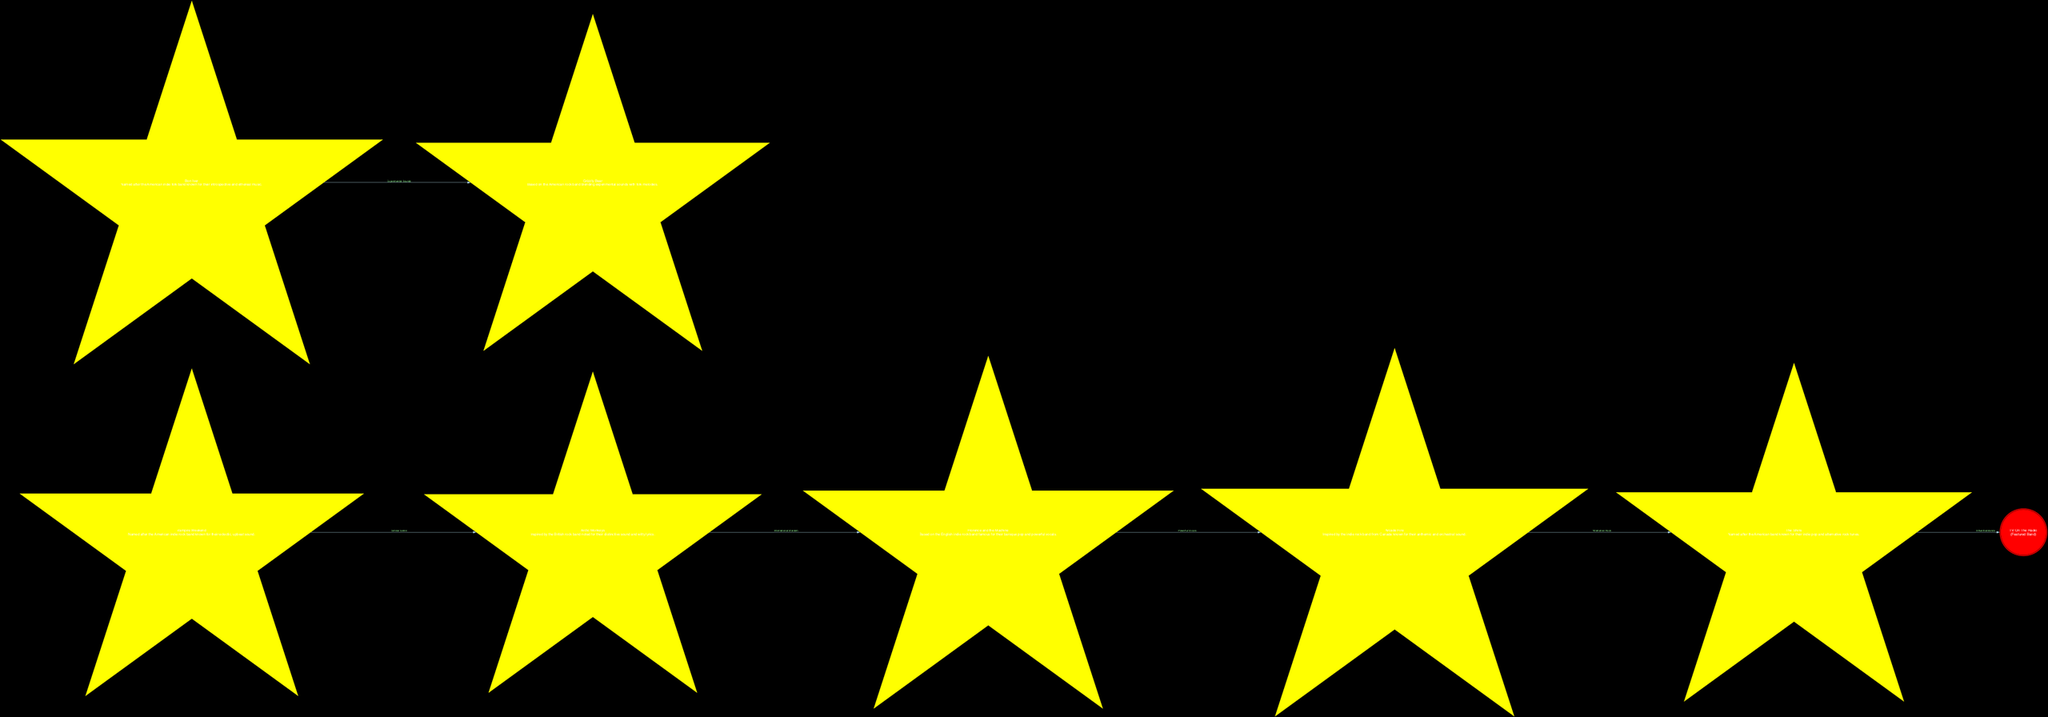What is the name of the constellation featuring the band known for blending genres like punk, soul, and electronic music? The constellation that features the band known for blending genres like punk, soul, and electronic music is "TV On The Radio". This is confirmed by identifying the specific constellation in the diagram.
Answer: TV On The Radio How many constellations are named after indie bands? By counting the number of individual nodes representing constellations in the diagram, we find that there are eight constellations named after indie bands.
Answer: 8 Which constellation is connected to "The Shins" through the relationship of "Influential Bands"? The connection labeled "Influential Bands" coming from "The Shins" points to "TV On The Radio". Therefore, the constellation connected to "The Shins" through this relationship is "TV On The Radio".
Answer: TV On The Radio What type of connection is illustrated between "Florence and the Machine" and "Arcade Fire"? The diagram shows a connection labeled "Powerful Vocals" between "Florence and the Machine" and "Arcade Fire". This connection indicates the qualitative relationship based on their musical characteristics.
Answer: Powerful Vocals Which indie rock band has a constellation named after them that is recognized for their anthemic and orchestral sound? The band recognized for their anthemic and orchestral sound with a constellation named after them is "Arcade Fire". This is confirmed by the diagram's labeling of the constellation.
Answer: Arcade Fire What is the relationship type between "Arctic Monkeys" and "Florence and the Machine"? The relationship type between "Arctic Monkeys" and "Florence and the Machine" is described as "International Stardom" in the diagram. This indicates a particular genre of comparison.
Answer: International Stardom Which constellation is highlighted with a special emphasis as a featured band? The constellation highlighted with special emphasis as a featured band is "TV On The Radio". This is indicated by the unique styling of its node in the diagram.
Answer: TV On The Radio How many direct connections are there emanating from the constellation "Bon Iver"? By examining the edges in the diagram, we can see that "Bon Iver" has one direct connection leading to "Grizzly Bear". Therefore, there is one direct connection.
Answer: 1 